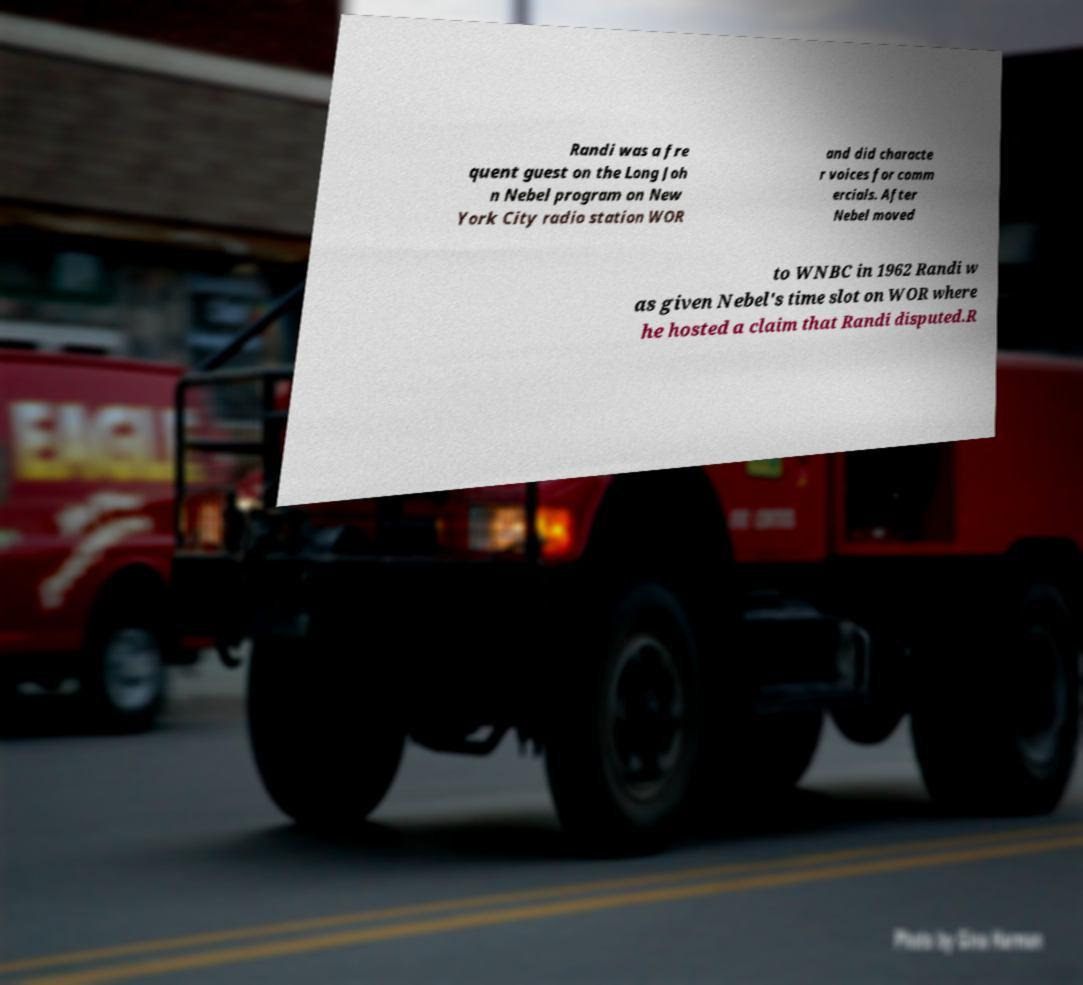Please read and relay the text visible in this image. What does it say? Randi was a fre quent guest on the Long Joh n Nebel program on New York City radio station WOR and did characte r voices for comm ercials. After Nebel moved to WNBC in 1962 Randi w as given Nebel's time slot on WOR where he hosted a claim that Randi disputed.R 